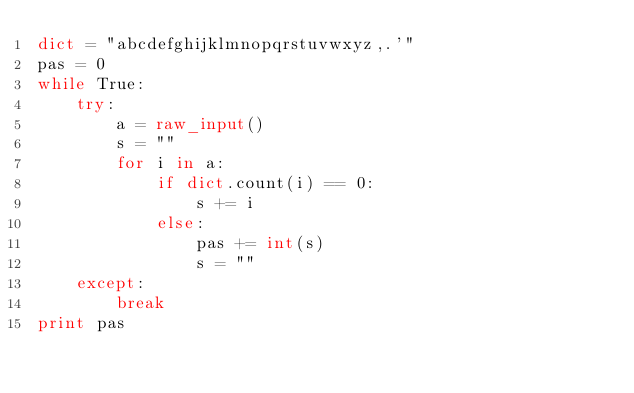Convert code to text. <code><loc_0><loc_0><loc_500><loc_500><_Python_>dict = "abcdefghijklmnopqrstuvwxyz,.'"
pas = 0
while True:
    try:
        a = raw_input()
        s = ""
        for i in a:
            if dict.count(i) == 0:
                s += i
            else:
                pas += int(s)
                s = ""
    except:
        break
print pas</code> 